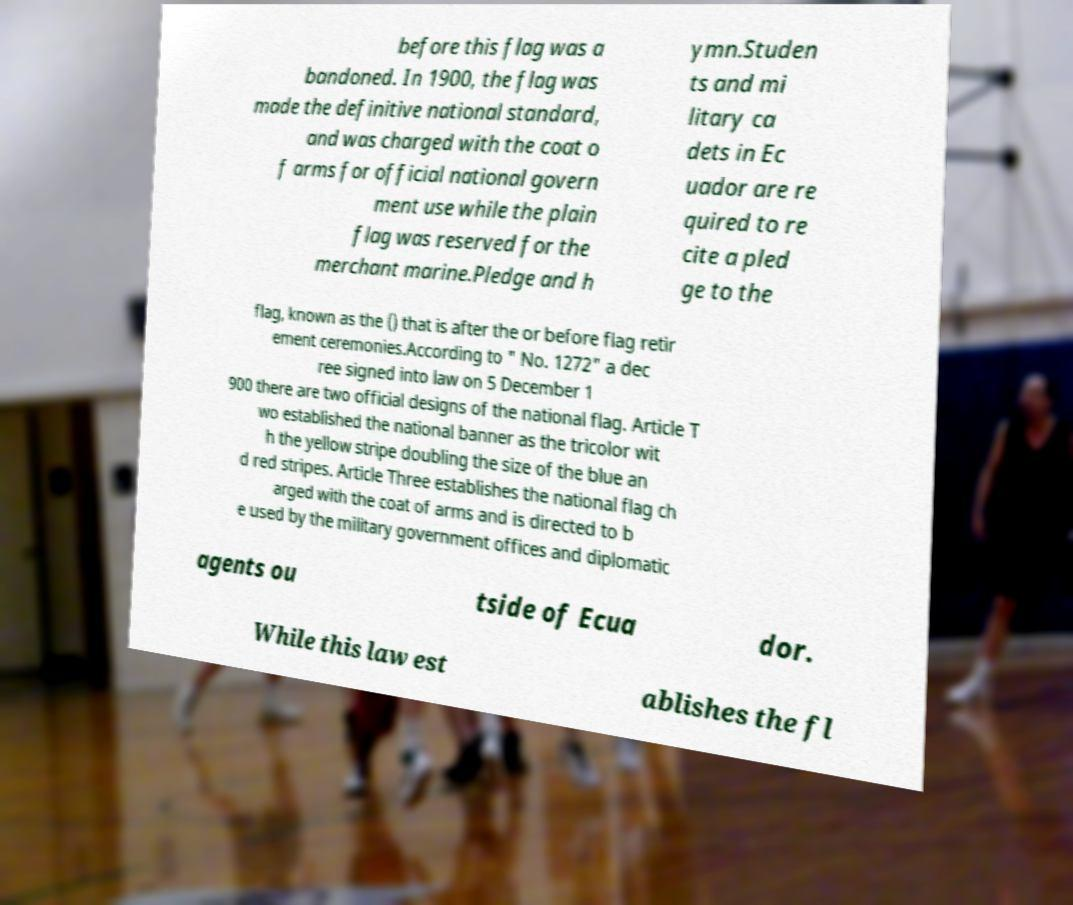There's text embedded in this image that I need extracted. Can you transcribe it verbatim? before this flag was a bandoned. In 1900, the flag was made the definitive national standard, and was charged with the coat o f arms for official national govern ment use while the plain flag was reserved for the merchant marine.Pledge and h ymn.Studen ts and mi litary ca dets in Ec uador are re quired to re cite a pled ge to the flag, known as the () that is after the or before flag retir ement ceremonies.According to " No. 1272" a dec ree signed into law on 5 December 1 900 there are two official designs of the national flag. Article T wo established the national banner as the tricolor wit h the yellow stripe doubling the size of the blue an d red stripes. Article Three establishes the national flag ch arged with the coat of arms and is directed to b e used by the military government offices and diplomatic agents ou tside of Ecua dor. While this law est ablishes the fl 